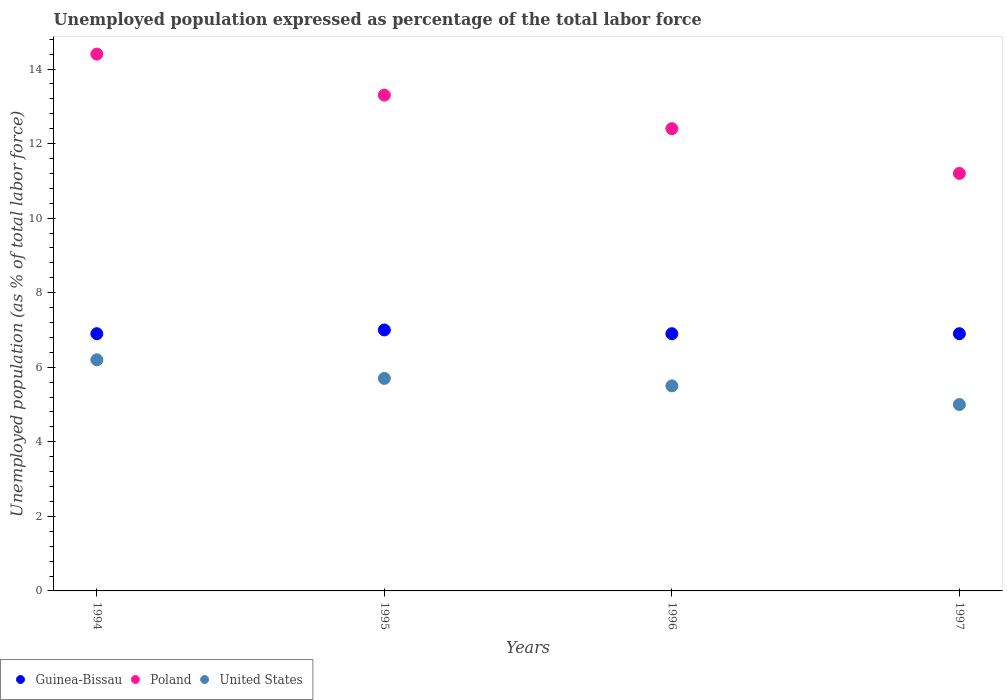How many different coloured dotlines are there?
Provide a succinct answer. 3. Is the number of dotlines equal to the number of legend labels?
Keep it short and to the point. Yes. What is the unemployment in in Guinea-Bissau in 1996?
Offer a terse response. 6.9. Across all years, what is the maximum unemployment in in United States?
Provide a succinct answer. 6.2. Across all years, what is the minimum unemployment in in Poland?
Provide a succinct answer. 11.2. In which year was the unemployment in in Poland maximum?
Your answer should be compact. 1994. In which year was the unemployment in in Guinea-Bissau minimum?
Your response must be concise. 1994. What is the total unemployment in in United States in the graph?
Your answer should be very brief. 22.4. What is the difference between the unemployment in in Guinea-Bissau in 1995 and that in 1996?
Your answer should be compact. 0.1. What is the difference between the unemployment in in Poland in 1995 and the unemployment in in United States in 1996?
Ensure brevity in your answer.  7.8. What is the average unemployment in in United States per year?
Offer a terse response. 5.6. In the year 1994, what is the difference between the unemployment in in Guinea-Bissau and unemployment in in Poland?
Your answer should be compact. -7.5. In how many years, is the unemployment in in United States greater than 14.4 %?
Provide a succinct answer. 0. What is the ratio of the unemployment in in Poland in 1995 to that in 1996?
Make the answer very short. 1.07. Is the unemployment in in Poland in 1994 less than that in 1996?
Make the answer very short. No. What is the difference between the highest and the second highest unemployment in in Guinea-Bissau?
Provide a short and direct response. 0.1. What is the difference between the highest and the lowest unemployment in in Guinea-Bissau?
Your answer should be very brief. 0.1. Is it the case that in every year, the sum of the unemployment in in United States and unemployment in in Guinea-Bissau  is greater than the unemployment in in Poland?
Ensure brevity in your answer.  No. Does the unemployment in in Poland monotonically increase over the years?
Your answer should be very brief. No. Does the graph contain any zero values?
Your answer should be very brief. No. What is the title of the graph?
Ensure brevity in your answer.  Unemployed population expressed as percentage of the total labor force. Does "American Samoa" appear as one of the legend labels in the graph?
Provide a short and direct response. No. What is the label or title of the Y-axis?
Your response must be concise. Unemployed population (as % of total labor force). What is the Unemployed population (as % of total labor force) in Guinea-Bissau in 1994?
Make the answer very short. 6.9. What is the Unemployed population (as % of total labor force) in Poland in 1994?
Give a very brief answer. 14.4. What is the Unemployed population (as % of total labor force) in United States in 1994?
Offer a terse response. 6.2. What is the Unemployed population (as % of total labor force) of Poland in 1995?
Offer a very short reply. 13.3. What is the Unemployed population (as % of total labor force) of United States in 1995?
Offer a very short reply. 5.7. What is the Unemployed population (as % of total labor force) in Guinea-Bissau in 1996?
Your answer should be compact. 6.9. What is the Unemployed population (as % of total labor force) of Poland in 1996?
Make the answer very short. 12.4. What is the Unemployed population (as % of total labor force) in Guinea-Bissau in 1997?
Give a very brief answer. 6.9. What is the Unemployed population (as % of total labor force) in Poland in 1997?
Your answer should be compact. 11.2. Across all years, what is the maximum Unemployed population (as % of total labor force) in Poland?
Provide a succinct answer. 14.4. Across all years, what is the maximum Unemployed population (as % of total labor force) in United States?
Offer a very short reply. 6.2. Across all years, what is the minimum Unemployed population (as % of total labor force) of Guinea-Bissau?
Provide a succinct answer. 6.9. Across all years, what is the minimum Unemployed population (as % of total labor force) of Poland?
Give a very brief answer. 11.2. What is the total Unemployed population (as % of total labor force) in Guinea-Bissau in the graph?
Keep it short and to the point. 27.7. What is the total Unemployed population (as % of total labor force) of Poland in the graph?
Give a very brief answer. 51.3. What is the total Unemployed population (as % of total labor force) of United States in the graph?
Make the answer very short. 22.4. What is the difference between the Unemployed population (as % of total labor force) in Poland in 1994 and that in 1996?
Offer a very short reply. 2. What is the difference between the Unemployed population (as % of total labor force) in Guinea-Bissau in 1994 and that in 1997?
Make the answer very short. 0. What is the difference between the Unemployed population (as % of total labor force) in Guinea-Bissau in 1995 and that in 1996?
Give a very brief answer. 0.1. What is the difference between the Unemployed population (as % of total labor force) in Guinea-Bissau in 1995 and that in 1997?
Offer a very short reply. 0.1. What is the difference between the Unemployed population (as % of total labor force) in Poland in 1995 and that in 1997?
Provide a short and direct response. 2.1. What is the difference between the Unemployed population (as % of total labor force) of Guinea-Bissau in 1996 and that in 1997?
Your answer should be very brief. 0. What is the difference between the Unemployed population (as % of total labor force) in Guinea-Bissau in 1994 and the Unemployed population (as % of total labor force) in Poland in 1995?
Your answer should be very brief. -6.4. What is the difference between the Unemployed population (as % of total labor force) in Guinea-Bissau in 1994 and the Unemployed population (as % of total labor force) in United States in 1995?
Ensure brevity in your answer.  1.2. What is the difference between the Unemployed population (as % of total labor force) of Poland in 1994 and the Unemployed population (as % of total labor force) of United States in 1995?
Your answer should be very brief. 8.7. What is the difference between the Unemployed population (as % of total labor force) in Guinea-Bissau in 1994 and the Unemployed population (as % of total labor force) in United States in 1996?
Ensure brevity in your answer.  1.4. What is the difference between the Unemployed population (as % of total labor force) of Guinea-Bissau in 1994 and the Unemployed population (as % of total labor force) of United States in 1997?
Your answer should be compact. 1.9. What is the difference between the Unemployed population (as % of total labor force) in Poland in 1994 and the Unemployed population (as % of total labor force) in United States in 1997?
Provide a succinct answer. 9.4. What is the difference between the Unemployed population (as % of total labor force) in Guinea-Bissau in 1995 and the Unemployed population (as % of total labor force) in Poland in 1996?
Your answer should be compact. -5.4. What is the difference between the Unemployed population (as % of total labor force) in Poland in 1995 and the Unemployed population (as % of total labor force) in United States in 1996?
Offer a terse response. 7.8. What is the difference between the Unemployed population (as % of total labor force) of Guinea-Bissau in 1995 and the Unemployed population (as % of total labor force) of Poland in 1997?
Offer a terse response. -4.2. What is the difference between the Unemployed population (as % of total labor force) in Guinea-Bissau in 1996 and the Unemployed population (as % of total labor force) in United States in 1997?
Your answer should be very brief. 1.9. What is the difference between the Unemployed population (as % of total labor force) in Poland in 1996 and the Unemployed population (as % of total labor force) in United States in 1997?
Your answer should be compact. 7.4. What is the average Unemployed population (as % of total labor force) of Guinea-Bissau per year?
Your answer should be very brief. 6.92. What is the average Unemployed population (as % of total labor force) in Poland per year?
Offer a terse response. 12.82. What is the average Unemployed population (as % of total labor force) of United States per year?
Offer a terse response. 5.6. In the year 1994, what is the difference between the Unemployed population (as % of total labor force) of Guinea-Bissau and Unemployed population (as % of total labor force) of Poland?
Your answer should be very brief. -7.5. In the year 1995, what is the difference between the Unemployed population (as % of total labor force) of Guinea-Bissau and Unemployed population (as % of total labor force) of United States?
Provide a short and direct response. 1.3. In the year 1996, what is the difference between the Unemployed population (as % of total labor force) in Guinea-Bissau and Unemployed population (as % of total labor force) in United States?
Your answer should be very brief. 1.4. In the year 1997, what is the difference between the Unemployed population (as % of total labor force) of Guinea-Bissau and Unemployed population (as % of total labor force) of United States?
Make the answer very short. 1.9. In the year 1997, what is the difference between the Unemployed population (as % of total labor force) in Poland and Unemployed population (as % of total labor force) in United States?
Ensure brevity in your answer.  6.2. What is the ratio of the Unemployed population (as % of total labor force) of Guinea-Bissau in 1994 to that in 1995?
Provide a short and direct response. 0.99. What is the ratio of the Unemployed population (as % of total labor force) in Poland in 1994 to that in 1995?
Offer a very short reply. 1.08. What is the ratio of the Unemployed population (as % of total labor force) in United States in 1994 to that in 1995?
Your response must be concise. 1.09. What is the ratio of the Unemployed population (as % of total labor force) of Poland in 1994 to that in 1996?
Your response must be concise. 1.16. What is the ratio of the Unemployed population (as % of total labor force) of United States in 1994 to that in 1996?
Provide a short and direct response. 1.13. What is the ratio of the Unemployed population (as % of total labor force) in Poland in 1994 to that in 1997?
Ensure brevity in your answer.  1.29. What is the ratio of the Unemployed population (as % of total labor force) of United States in 1994 to that in 1997?
Your answer should be compact. 1.24. What is the ratio of the Unemployed population (as % of total labor force) in Guinea-Bissau in 1995 to that in 1996?
Your response must be concise. 1.01. What is the ratio of the Unemployed population (as % of total labor force) in Poland in 1995 to that in 1996?
Give a very brief answer. 1.07. What is the ratio of the Unemployed population (as % of total labor force) of United States in 1995 to that in 1996?
Your answer should be compact. 1.04. What is the ratio of the Unemployed population (as % of total labor force) of Guinea-Bissau in 1995 to that in 1997?
Give a very brief answer. 1.01. What is the ratio of the Unemployed population (as % of total labor force) in Poland in 1995 to that in 1997?
Provide a succinct answer. 1.19. What is the ratio of the Unemployed population (as % of total labor force) of United States in 1995 to that in 1997?
Ensure brevity in your answer.  1.14. What is the ratio of the Unemployed population (as % of total labor force) of Poland in 1996 to that in 1997?
Provide a short and direct response. 1.11. What is the difference between the highest and the second highest Unemployed population (as % of total labor force) in Guinea-Bissau?
Your answer should be compact. 0.1. What is the difference between the highest and the second highest Unemployed population (as % of total labor force) in Poland?
Provide a short and direct response. 1.1. What is the difference between the highest and the second highest Unemployed population (as % of total labor force) of United States?
Offer a terse response. 0.5. What is the difference between the highest and the lowest Unemployed population (as % of total labor force) in Guinea-Bissau?
Your answer should be compact. 0.1. What is the difference between the highest and the lowest Unemployed population (as % of total labor force) of United States?
Offer a terse response. 1.2. 